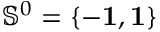<formula> <loc_0><loc_0><loc_500><loc_500>{ \mathbb { S } } ^ { 0 } = \{ - { 1 } , { 1 } \}</formula> 